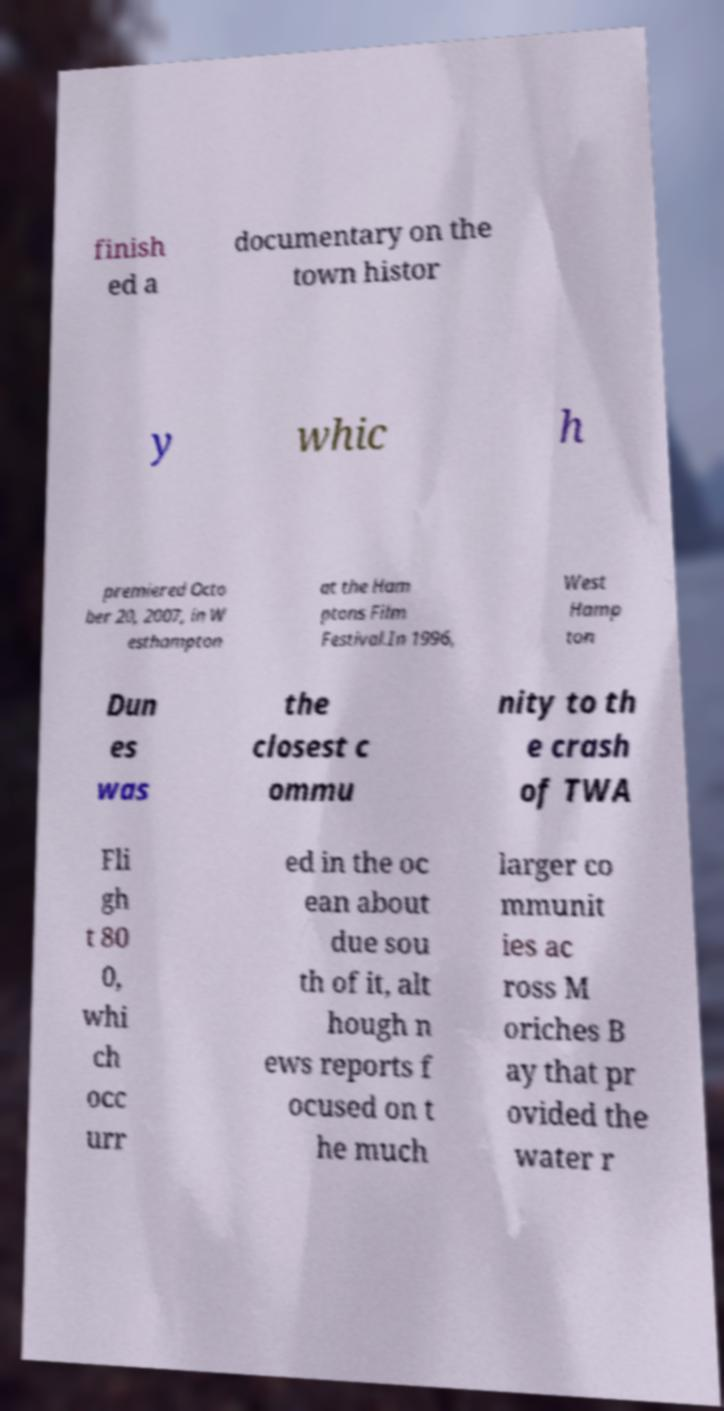I need the written content from this picture converted into text. Can you do that? finish ed a documentary on the town histor y whic h premiered Octo ber 20, 2007, in W esthampton at the Ham ptons Film Festival.In 1996, West Hamp ton Dun es was the closest c ommu nity to th e crash of TWA Fli gh t 80 0, whi ch occ urr ed in the oc ean about due sou th of it, alt hough n ews reports f ocused on t he much larger co mmunit ies ac ross M oriches B ay that pr ovided the water r 